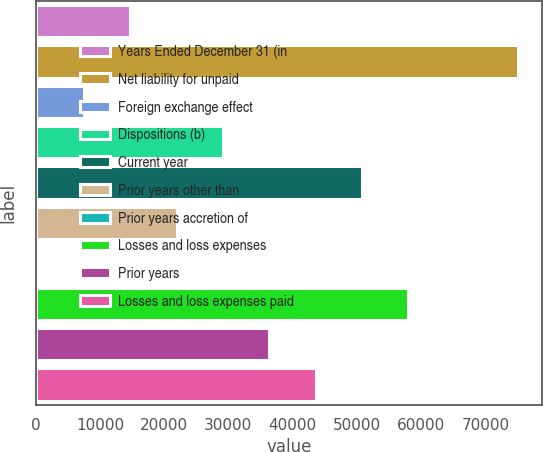Convert chart. <chart><loc_0><loc_0><loc_500><loc_500><bar_chart><fcel>Years Ended December 31 (in<fcel>Net liability for unpaid<fcel>Foreign exchange effect<fcel>Dispositions (b)<fcel>Current year<fcel>Prior years other than<fcel>Prior years accretion of<fcel>Losses and loss expenses<fcel>Prior years<fcel>Losses and loss expenses paid<nl><fcel>14741.4<fcel>75113.2<fcel>7527.2<fcel>29169.8<fcel>50812.4<fcel>21955.6<fcel>313<fcel>58026.6<fcel>36384<fcel>43598.2<nl></chart> 